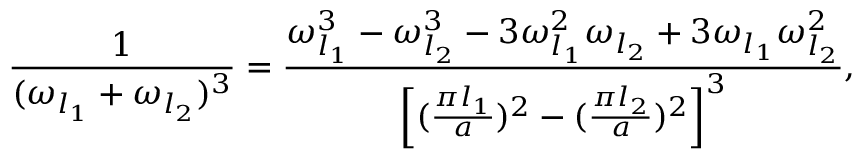<formula> <loc_0><loc_0><loc_500><loc_500>{ \frac { 1 } { ( \omega _ { l _ { 1 } } + \omega _ { l _ { 2 } } ) ^ { 3 } } } = { \frac { \omega _ { l _ { 1 } } ^ { 3 } - \omega _ { l _ { 2 } } ^ { 3 } - 3 \omega _ { l _ { 1 } } ^ { 2 } \omega _ { l _ { 2 } } + 3 \omega _ { l _ { 1 } } \omega _ { l _ { 2 } } ^ { 2 } } { \left [ ( { \frac { \pi l _ { 1 } } { a } } ) ^ { 2 } - ( { \frac { \pi l _ { 2 } } { a } } ) ^ { 2 } \right ] ^ { 3 } } } ,</formula> 